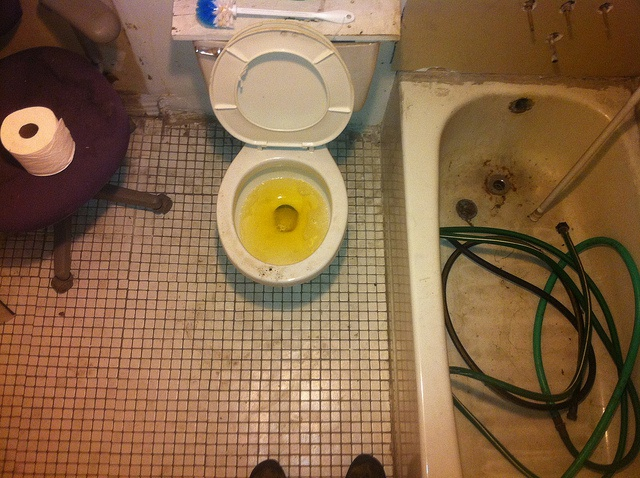Describe the objects in this image and their specific colors. I can see sink in black, maroon, and olive tones and toilet in black, tan, and gold tones in this image. 